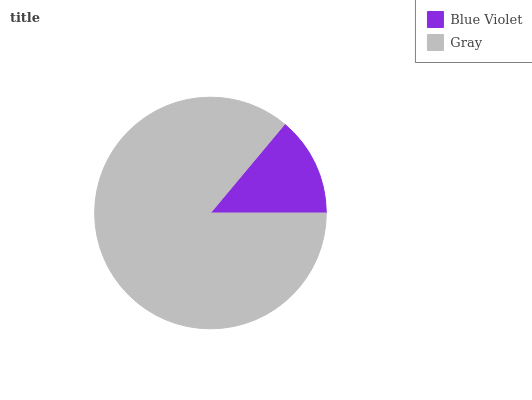Is Blue Violet the minimum?
Answer yes or no. Yes. Is Gray the maximum?
Answer yes or no. Yes. Is Gray the minimum?
Answer yes or no. No. Is Gray greater than Blue Violet?
Answer yes or no. Yes. Is Blue Violet less than Gray?
Answer yes or no. Yes. Is Blue Violet greater than Gray?
Answer yes or no. No. Is Gray less than Blue Violet?
Answer yes or no. No. Is Gray the high median?
Answer yes or no. Yes. Is Blue Violet the low median?
Answer yes or no. Yes. Is Blue Violet the high median?
Answer yes or no. No. Is Gray the low median?
Answer yes or no. No. 